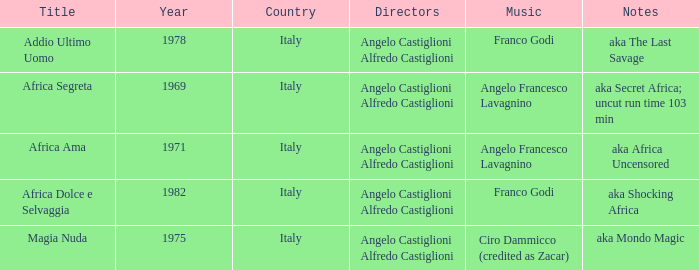Which music has the notes of AKA Africa Uncensored? Angelo Francesco Lavagnino. 